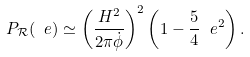Convert formula to latex. <formula><loc_0><loc_0><loc_500><loc_500>P _ { \mathcal { R } } ( \ e ) \simeq \left ( \frac { H ^ { 2 } } { 2 \pi \dot { \phi } } \right ) ^ { 2 } \left ( 1 - \frac { 5 } { 4 } \ e ^ { 2 } \right ) .</formula> 